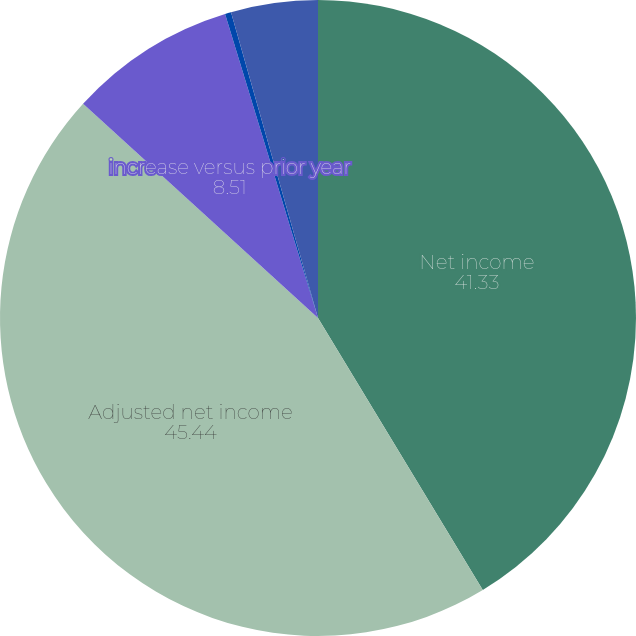Convert chart to OTSL. <chart><loc_0><loc_0><loc_500><loc_500><pie_chart><fcel>Net income<fcel>Adjusted net income<fcel>increase versus prior year<fcel>Earnings per share-diluted<fcel>Adjusted earnings per<nl><fcel>41.33%<fcel>45.44%<fcel>8.51%<fcel>0.31%<fcel>4.41%<nl></chart> 